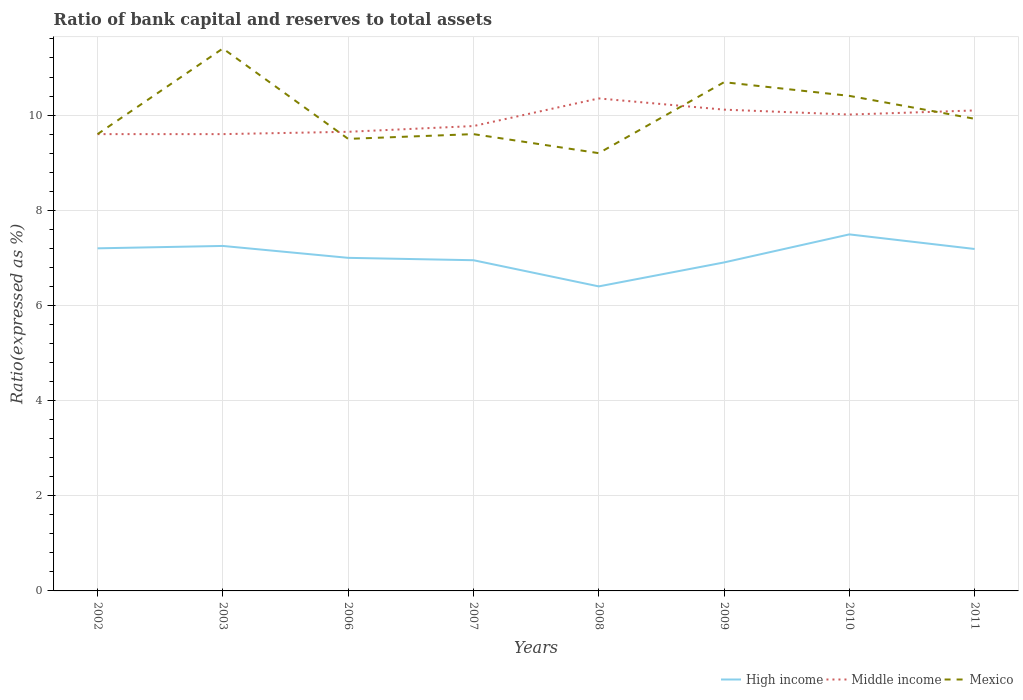Is the number of lines equal to the number of legend labels?
Make the answer very short. Yes. Across all years, what is the maximum ratio of bank capital and reserves to total assets in High income?
Your answer should be compact. 6.4. What is the total ratio of bank capital and reserves to total assets in High income in the graph?
Ensure brevity in your answer.  -0.59. What is the difference between the highest and the second highest ratio of bank capital and reserves to total assets in High income?
Offer a very short reply. 1.09. How many lines are there?
Keep it short and to the point. 3. Does the graph contain any zero values?
Offer a terse response. No. Does the graph contain grids?
Keep it short and to the point. Yes. How many legend labels are there?
Offer a terse response. 3. How are the legend labels stacked?
Ensure brevity in your answer.  Horizontal. What is the title of the graph?
Your answer should be very brief. Ratio of bank capital and reserves to total assets. What is the label or title of the Y-axis?
Keep it short and to the point. Ratio(expressed as %). What is the Ratio(expressed as %) of High income in 2002?
Make the answer very short. 7.2. What is the Ratio(expressed as %) in High income in 2003?
Make the answer very short. 7.25. What is the Ratio(expressed as %) of Middle income in 2003?
Your answer should be compact. 9.6. What is the Ratio(expressed as %) of Mexico in 2003?
Offer a terse response. 11.4. What is the Ratio(expressed as %) of High income in 2006?
Provide a succinct answer. 7. What is the Ratio(expressed as %) in Middle income in 2006?
Ensure brevity in your answer.  9.65. What is the Ratio(expressed as %) of Mexico in 2006?
Offer a terse response. 9.5. What is the Ratio(expressed as %) in High income in 2007?
Provide a succinct answer. 6.95. What is the Ratio(expressed as %) of Middle income in 2007?
Provide a short and direct response. 9.77. What is the Ratio(expressed as %) in Mexico in 2007?
Your response must be concise. 9.6. What is the Ratio(expressed as %) of High income in 2008?
Make the answer very short. 6.4. What is the Ratio(expressed as %) of Middle income in 2008?
Make the answer very short. 10.35. What is the Ratio(expressed as %) in High income in 2009?
Your answer should be very brief. 6.9. What is the Ratio(expressed as %) of Middle income in 2009?
Your response must be concise. 10.11. What is the Ratio(expressed as %) in Mexico in 2009?
Your answer should be very brief. 10.69. What is the Ratio(expressed as %) in High income in 2010?
Provide a short and direct response. 7.49. What is the Ratio(expressed as %) of Middle income in 2010?
Make the answer very short. 10.01. What is the Ratio(expressed as %) of Mexico in 2010?
Provide a succinct answer. 10.4. What is the Ratio(expressed as %) in High income in 2011?
Offer a very short reply. 7.19. What is the Ratio(expressed as %) of Middle income in 2011?
Make the answer very short. 10.1. What is the Ratio(expressed as %) in Mexico in 2011?
Give a very brief answer. 9.92. Across all years, what is the maximum Ratio(expressed as %) of High income?
Provide a succinct answer. 7.49. Across all years, what is the maximum Ratio(expressed as %) of Middle income?
Offer a very short reply. 10.35. Across all years, what is the maximum Ratio(expressed as %) in Mexico?
Give a very brief answer. 11.4. Across all years, what is the minimum Ratio(expressed as %) in High income?
Your response must be concise. 6.4. Across all years, what is the minimum Ratio(expressed as %) of Middle income?
Make the answer very short. 9.6. What is the total Ratio(expressed as %) in High income in the graph?
Give a very brief answer. 56.38. What is the total Ratio(expressed as %) in Middle income in the graph?
Your answer should be compact. 79.19. What is the total Ratio(expressed as %) of Mexico in the graph?
Your answer should be very brief. 80.32. What is the difference between the Ratio(expressed as %) of Mexico in 2002 and that in 2003?
Provide a short and direct response. -1.8. What is the difference between the Ratio(expressed as %) in Middle income in 2002 and that in 2006?
Your answer should be compact. -0.05. What is the difference between the Ratio(expressed as %) in Mexico in 2002 and that in 2006?
Your answer should be very brief. 0.1. What is the difference between the Ratio(expressed as %) of Middle income in 2002 and that in 2007?
Provide a short and direct response. -0.17. What is the difference between the Ratio(expressed as %) in Middle income in 2002 and that in 2008?
Give a very brief answer. -0.75. What is the difference between the Ratio(expressed as %) in High income in 2002 and that in 2009?
Provide a succinct answer. 0.3. What is the difference between the Ratio(expressed as %) of Middle income in 2002 and that in 2009?
Your response must be concise. -0.51. What is the difference between the Ratio(expressed as %) of Mexico in 2002 and that in 2009?
Offer a very short reply. -1.09. What is the difference between the Ratio(expressed as %) in High income in 2002 and that in 2010?
Offer a terse response. -0.29. What is the difference between the Ratio(expressed as %) of Middle income in 2002 and that in 2010?
Provide a succinct answer. -0.41. What is the difference between the Ratio(expressed as %) in Mexico in 2002 and that in 2010?
Your response must be concise. -0.8. What is the difference between the Ratio(expressed as %) in High income in 2002 and that in 2011?
Make the answer very short. 0.01. What is the difference between the Ratio(expressed as %) of Middle income in 2002 and that in 2011?
Your response must be concise. -0.5. What is the difference between the Ratio(expressed as %) of Mexico in 2002 and that in 2011?
Provide a succinct answer. -0.32. What is the difference between the Ratio(expressed as %) of High income in 2003 and that in 2006?
Offer a terse response. 0.25. What is the difference between the Ratio(expressed as %) in Middle income in 2003 and that in 2006?
Your answer should be compact. -0.05. What is the difference between the Ratio(expressed as %) of Middle income in 2003 and that in 2007?
Offer a very short reply. -0.17. What is the difference between the Ratio(expressed as %) of High income in 2003 and that in 2008?
Make the answer very short. 0.85. What is the difference between the Ratio(expressed as %) of Middle income in 2003 and that in 2008?
Provide a short and direct response. -0.75. What is the difference between the Ratio(expressed as %) in High income in 2003 and that in 2009?
Your answer should be compact. 0.35. What is the difference between the Ratio(expressed as %) of Middle income in 2003 and that in 2009?
Keep it short and to the point. -0.51. What is the difference between the Ratio(expressed as %) in Mexico in 2003 and that in 2009?
Your answer should be compact. 0.71. What is the difference between the Ratio(expressed as %) of High income in 2003 and that in 2010?
Ensure brevity in your answer.  -0.24. What is the difference between the Ratio(expressed as %) of Middle income in 2003 and that in 2010?
Provide a succinct answer. -0.41. What is the difference between the Ratio(expressed as %) of High income in 2003 and that in 2011?
Your answer should be very brief. 0.06. What is the difference between the Ratio(expressed as %) in Middle income in 2003 and that in 2011?
Your response must be concise. -0.5. What is the difference between the Ratio(expressed as %) in Mexico in 2003 and that in 2011?
Keep it short and to the point. 1.48. What is the difference between the Ratio(expressed as %) in High income in 2006 and that in 2007?
Provide a short and direct response. 0.05. What is the difference between the Ratio(expressed as %) in Middle income in 2006 and that in 2007?
Your response must be concise. -0.12. What is the difference between the Ratio(expressed as %) of High income in 2006 and that in 2008?
Provide a short and direct response. 0.6. What is the difference between the Ratio(expressed as %) of Middle income in 2006 and that in 2008?
Give a very brief answer. -0.7. What is the difference between the Ratio(expressed as %) in High income in 2006 and that in 2009?
Your answer should be compact. 0.1. What is the difference between the Ratio(expressed as %) of Middle income in 2006 and that in 2009?
Your response must be concise. -0.47. What is the difference between the Ratio(expressed as %) in Mexico in 2006 and that in 2009?
Provide a short and direct response. -1.19. What is the difference between the Ratio(expressed as %) of High income in 2006 and that in 2010?
Keep it short and to the point. -0.49. What is the difference between the Ratio(expressed as %) in Middle income in 2006 and that in 2010?
Keep it short and to the point. -0.36. What is the difference between the Ratio(expressed as %) of Mexico in 2006 and that in 2010?
Your response must be concise. -0.9. What is the difference between the Ratio(expressed as %) of High income in 2006 and that in 2011?
Give a very brief answer. -0.19. What is the difference between the Ratio(expressed as %) in Middle income in 2006 and that in 2011?
Make the answer very short. -0.45. What is the difference between the Ratio(expressed as %) in Mexico in 2006 and that in 2011?
Keep it short and to the point. -0.42. What is the difference between the Ratio(expressed as %) in High income in 2007 and that in 2008?
Your answer should be compact. 0.55. What is the difference between the Ratio(expressed as %) of Middle income in 2007 and that in 2008?
Offer a terse response. -0.58. What is the difference between the Ratio(expressed as %) of High income in 2007 and that in 2009?
Provide a short and direct response. 0.05. What is the difference between the Ratio(expressed as %) of Middle income in 2007 and that in 2009?
Your answer should be very brief. -0.34. What is the difference between the Ratio(expressed as %) of Mexico in 2007 and that in 2009?
Make the answer very short. -1.09. What is the difference between the Ratio(expressed as %) in High income in 2007 and that in 2010?
Keep it short and to the point. -0.54. What is the difference between the Ratio(expressed as %) in Middle income in 2007 and that in 2010?
Offer a very short reply. -0.24. What is the difference between the Ratio(expressed as %) in Mexico in 2007 and that in 2010?
Ensure brevity in your answer.  -0.8. What is the difference between the Ratio(expressed as %) in High income in 2007 and that in 2011?
Provide a short and direct response. -0.24. What is the difference between the Ratio(expressed as %) of Middle income in 2007 and that in 2011?
Ensure brevity in your answer.  -0.33. What is the difference between the Ratio(expressed as %) in Mexico in 2007 and that in 2011?
Your answer should be compact. -0.32. What is the difference between the Ratio(expressed as %) in High income in 2008 and that in 2009?
Give a very brief answer. -0.5. What is the difference between the Ratio(expressed as %) of Middle income in 2008 and that in 2009?
Keep it short and to the point. 0.24. What is the difference between the Ratio(expressed as %) of Mexico in 2008 and that in 2009?
Ensure brevity in your answer.  -1.49. What is the difference between the Ratio(expressed as %) of High income in 2008 and that in 2010?
Provide a short and direct response. -1.09. What is the difference between the Ratio(expressed as %) in Middle income in 2008 and that in 2010?
Your answer should be compact. 0.34. What is the difference between the Ratio(expressed as %) of Mexico in 2008 and that in 2010?
Offer a very short reply. -1.2. What is the difference between the Ratio(expressed as %) in High income in 2008 and that in 2011?
Your answer should be very brief. -0.79. What is the difference between the Ratio(expressed as %) of Middle income in 2008 and that in 2011?
Provide a short and direct response. 0.25. What is the difference between the Ratio(expressed as %) in Mexico in 2008 and that in 2011?
Make the answer very short. -0.72. What is the difference between the Ratio(expressed as %) of High income in 2009 and that in 2010?
Offer a very short reply. -0.59. What is the difference between the Ratio(expressed as %) of Middle income in 2009 and that in 2010?
Your answer should be very brief. 0.1. What is the difference between the Ratio(expressed as %) of Mexico in 2009 and that in 2010?
Your answer should be compact. 0.29. What is the difference between the Ratio(expressed as %) in High income in 2009 and that in 2011?
Give a very brief answer. -0.28. What is the difference between the Ratio(expressed as %) in Middle income in 2009 and that in 2011?
Your response must be concise. 0.02. What is the difference between the Ratio(expressed as %) of Mexico in 2009 and that in 2011?
Keep it short and to the point. 0.77. What is the difference between the Ratio(expressed as %) in High income in 2010 and that in 2011?
Offer a terse response. 0.31. What is the difference between the Ratio(expressed as %) in Middle income in 2010 and that in 2011?
Your response must be concise. -0.09. What is the difference between the Ratio(expressed as %) of Mexico in 2010 and that in 2011?
Provide a short and direct response. 0.48. What is the difference between the Ratio(expressed as %) of High income in 2002 and the Ratio(expressed as %) of Middle income in 2003?
Provide a succinct answer. -2.4. What is the difference between the Ratio(expressed as %) in High income in 2002 and the Ratio(expressed as %) in Mexico in 2003?
Provide a short and direct response. -4.2. What is the difference between the Ratio(expressed as %) of High income in 2002 and the Ratio(expressed as %) of Middle income in 2006?
Ensure brevity in your answer.  -2.45. What is the difference between the Ratio(expressed as %) in High income in 2002 and the Ratio(expressed as %) in Middle income in 2007?
Offer a terse response. -2.57. What is the difference between the Ratio(expressed as %) of High income in 2002 and the Ratio(expressed as %) of Middle income in 2008?
Give a very brief answer. -3.15. What is the difference between the Ratio(expressed as %) of High income in 2002 and the Ratio(expressed as %) of Mexico in 2008?
Provide a short and direct response. -2. What is the difference between the Ratio(expressed as %) in High income in 2002 and the Ratio(expressed as %) in Middle income in 2009?
Offer a terse response. -2.91. What is the difference between the Ratio(expressed as %) of High income in 2002 and the Ratio(expressed as %) of Mexico in 2009?
Offer a very short reply. -3.49. What is the difference between the Ratio(expressed as %) in Middle income in 2002 and the Ratio(expressed as %) in Mexico in 2009?
Offer a very short reply. -1.09. What is the difference between the Ratio(expressed as %) of High income in 2002 and the Ratio(expressed as %) of Middle income in 2010?
Offer a terse response. -2.81. What is the difference between the Ratio(expressed as %) in High income in 2002 and the Ratio(expressed as %) in Mexico in 2010?
Offer a very short reply. -3.2. What is the difference between the Ratio(expressed as %) of Middle income in 2002 and the Ratio(expressed as %) of Mexico in 2010?
Offer a very short reply. -0.8. What is the difference between the Ratio(expressed as %) in High income in 2002 and the Ratio(expressed as %) in Middle income in 2011?
Your answer should be very brief. -2.9. What is the difference between the Ratio(expressed as %) in High income in 2002 and the Ratio(expressed as %) in Mexico in 2011?
Ensure brevity in your answer.  -2.72. What is the difference between the Ratio(expressed as %) of Middle income in 2002 and the Ratio(expressed as %) of Mexico in 2011?
Your answer should be compact. -0.32. What is the difference between the Ratio(expressed as %) in High income in 2003 and the Ratio(expressed as %) in Middle income in 2006?
Offer a very short reply. -2.4. What is the difference between the Ratio(expressed as %) of High income in 2003 and the Ratio(expressed as %) of Mexico in 2006?
Provide a short and direct response. -2.25. What is the difference between the Ratio(expressed as %) of High income in 2003 and the Ratio(expressed as %) of Middle income in 2007?
Your response must be concise. -2.52. What is the difference between the Ratio(expressed as %) of High income in 2003 and the Ratio(expressed as %) of Mexico in 2007?
Your answer should be very brief. -2.35. What is the difference between the Ratio(expressed as %) of Middle income in 2003 and the Ratio(expressed as %) of Mexico in 2007?
Make the answer very short. 0. What is the difference between the Ratio(expressed as %) of High income in 2003 and the Ratio(expressed as %) of Middle income in 2008?
Offer a terse response. -3.1. What is the difference between the Ratio(expressed as %) of High income in 2003 and the Ratio(expressed as %) of Mexico in 2008?
Your response must be concise. -1.95. What is the difference between the Ratio(expressed as %) of Middle income in 2003 and the Ratio(expressed as %) of Mexico in 2008?
Provide a short and direct response. 0.4. What is the difference between the Ratio(expressed as %) of High income in 2003 and the Ratio(expressed as %) of Middle income in 2009?
Make the answer very short. -2.86. What is the difference between the Ratio(expressed as %) of High income in 2003 and the Ratio(expressed as %) of Mexico in 2009?
Your answer should be very brief. -3.44. What is the difference between the Ratio(expressed as %) in Middle income in 2003 and the Ratio(expressed as %) in Mexico in 2009?
Provide a succinct answer. -1.09. What is the difference between the Ratio(expressed as %) in High income in 2003 and the Ratio(expressed as %) in Middle income in 2010?
Offer a terse response. -2.76. What is the difference between the Ratio(expressed as %) in High income in 2003 and the Ratio(expressed as %) in Mexico in 2010?
Offer a terse response. -3.15. What is the difference between the Ratio(expressed as %) in Middle income in 2003 and the Ratio(expressed as %) in Mexico in 2010?
Your answer should be very brief. -0.8. What is the difference between the Ratio(expressed as %) in High income in 2003 and the Ratio(expressed as %) in Middle income in 2011?
Your answer should be compact. -2.85. What is the difference between the Ratio(expressed as %) of High income in 2003 and the Ratio(expressed as %) of Mexico in 2011?
Offer a very short reply. -2.67. What is the difference between the Ratio(expressed as %) of Middle income in 2003 and the Ratio(expressed as %) of Mexico in 2011?
Keep it short and to the point. -0.32. What is the difference between the Ratio(expressed as %) in High income in 2006 and the Ratio(expressed as %) in Middle income in 2007?
Ensure brevity in your answer.  -2.77. What is the difference between the Ratio(expressed as %) of Middle income in 2006 and the Ratio(expressed as %) of Mexico in 2007?
Give a very brief answer. 0.05. What is the difference between the Ratio(expressed as %) of High income in 2006 and the Ratio(expressed as %) of Middle income in 2008?
Provide a succinct answer. -3.35. What is the difference between the Ratio(expressed as %) of High income in 2006 and the Ratio(expressed as %) of Mexico in 2008?
Ensure brevity in your answer.  -2.2. What is the difference between the Ratio(expressed as %) of Middle income in 2006 and the Ratio(expressed as %) of Mexico in 2008?
Offer a very short reply. 0.45. What is the difference between the Ratio(expressed as %) of High income in 2006 and the Ratio(expressed as %) of Middle income in 2009?
Make the answer very short. -3.11. What is the difference between the Ratio(expressed as %) in High income in 2006 and the Ratio(expressed as %) in Mexico in 2009?
Provide a short and direct response. -3.69. What is the difference between the Ratio(expressed as %) in Middle income in 2006 and the Ratio(expressed as %) in Mexico in 2009?
Make the answer very short. -1.04. What is the difference between the Ratio(expressed as %) in High income in 2006 and the Ratio(expressed as %) in Middle income in 2010?
Your answer should be compact. -3.01. What is the difference between the Ratio(expressed as %) of High income in 2006 and the Ratio(expressed as %) of Mexico in 2010?
Provide a short and direct response. -3.4. What is the difference between the Ratio(expressed as %) of Middle income in 2006 and the Ratio(expressed as %) of Mexico in 2010?
Provide a succinct answer. -0.75. What is the difference between the Ratio(expressed as %) in High income in 2006 and the Ratio(expressed as %) in Middle income in 2011?
Provide a short and direct response. -3.1. What is the difference between the Ratio(expressed as %) in High income in 2006 and the Ratio(expressed as %) in Mexico in 2011?
Provide a short and direct response. -2.92. What is the difference between the Ratio(expressed as %) of Middle income in 2006 and the Ratio(expressed as %) of Mexico in 2011?
Your answer should be very brief. -0.27. What is the difference between the Ratio(expressed as %) of High income in 2007 and the Ratio(expressed as %) of Mexico in 2008?
Keep it short and to the point. -2.25. What is the difference between the Ratio(expressed as %) of Middle income in 2007 and the Ratio(expressed as %) of Mexico in 2008?
Offer a very short reply. 0.57. What is the difference between the Ratio(expressed as %) in High income in 2007 and the Ratio(expressed as %) in Middle income in 2009?
Keep it short and to the point. -3.16. What is the difference between the Ratio(expressed as %) of High income in 2007 and the Ratio(expressed as %) of Mexico in 2009?
Offer a terse response. -3.74. What is the difference between the Ratio(expressed as %) in Middle income in 2007 and the Ratio(expressed as %) in Mexico in 2009?
Provide a succinct answer. -0.92. What is the difference between the Ratio(expressed as %) of High income in 2007 and the Ratio(expressed as %) of Middle income in 2010?
Your response must be concise. -3.06. What is the difference between the Ratio(expressed as %) in High income in 2007 and the Ratio(expressed as %) in Mexico in 2010?
Your response must be concise. -3.45. What is the difference between the Ratio(expressed as %) in Middle income in 2007 and the Ratio(expressed as %) in Mexico in 2010?
Provide a short and direct response. -0.63. What is the difference between the Ratio(expressed as %) of High income in 2007 and the Ratio(expressed as %) of Middle income in 2011?
Provide a succinct answer. -3.15. What is the difference between the Ratio(expressed as %) in High income in 2007 and the Ratio(expressed as %) in Mexico in 2011?
Ensure brevity in your answer.  -2.97. What is the difference between the Ratio(expressed as %) in Middle income in 2007 and the Ratio(expressed as %) in Mexico in 2011?
Your answer should be compact. -0.15. What is the difference between the Ratio(expressed as %) of High income in 2008 and the Ratio(expressed as %) of Middle income in 2009?
Provide a succinct answer. -3.71. What is the difference between the Ratio(expressed as %) in High income in 2008 and the Ratio(expressed as %) in Mexico in 2009?
Give a very brief answer. -4.29. What is the difference between the Ratio(expressed as %) of Middle income in 2008 and the Ratio(expressed as %) of Mexico in 2009?
Ensure brevity in your answer.  -0.34. What is the difference between the Ratio(expressed as %) of High income in 2008 and the Ratio(expressed as %) of Middle income in 2010?
Make the answer very short. -3.61. What is the difference between the Ratio(expressed as %) of High income in 2008 and the Ratio(expressed as %) of Mexico in 2010?
Ensure brevity in your answer.  -4. What is the difference between the Ratio(expressed as %) of Middle income in 2008 and the Ratio(expressed as %) of Mexico in 2010?
Give a very brief answer. -0.05. What is the difference between the Ratio(expressed as %) of High income in 2008 and the Ratio(expressed as %) of Middle income in 2011?
Your response must be concise. -3.7. What is the difference between the Ratio(expressed as %) in High income in 2008 and the Ratio(expressed as %) in Mexico in 2011?
Your response must be concise. -3.52. What is the difference between the Ratio(expressed as %) in Middle income in 2008 and the Ratio(expressed as %) in Mexico in 2011?
Provide a short and direct response. 0.43. What is the difference between the Ratio(expressed as %) of High income in 2009 and the Ratio(expressed as %) of Middle income in 2010?
Ensure brevity in your answer.  -3.11. What is the difference between the Ratio(expressed as %) in High income in 2009 and the Ratio(expressed as %) in Mexico in 2010?
Provide a succinct answer. -3.5. What is the difference between the Ratio(expressed as %) in Middle income in 2009 and the Ratio(expressed as %) in Mexico in 2010?
Offer a terse response. -0.29. What is the difference between the Ratio(expressed as %) of High income in 2009 and the Ratio(expressed as %) of Middle income in 2011?
Offer a terse response. -3.19. What is the difference between the Ratio(expressed as %) of High income in 2009 and the Ratio(expressed as %) of Mexico in 2011?
Keep it short and to the point. -3.02. What is the difference between the Ratio(expressed as %) in Middle income in 2009 and the Ratio(expressed as %) in Mexico in 2011?
Keep it short and to the point. 0.19. What is the difference between the Ratio(expressed as %) of High income in 2010 and the Ratio(expressed as %) of Middle income in 2011?
Provide a succinct answer. -2.6. What is the difference between the Ratio(expressed as %) in High income in 2010 and the Ratio(expressed as %) in Mexico in 2011?
Offer a very short reply. -2.43. What is the difference between the Ratio(expressed as %) in Middle income in 2010 and the Ratio(expressed as %) in Mexico in 2011?
Keep it short and to the point. 0.09. What is the average Ratio(expressed as %) in High income per year?
Ensure brevity in your answer.  7.05. What is the average Ratio(expressed as %) of Middle income per year?
Make the answer very short. 9.9. What is the average Ratio(expressed as %) in Mexico per year?
Make the answer very short. 10.04. In the year 2003, what is the difference between the Ratio(expressed as %) of High income and Ratio(expressed as %) of Middle income?
Make the answer very short. -2.35. In the year 2003, what is the difference between the Ratio(expressed as %) of High income and Ratio(expressed as %) of Mexico?
Keep it short and to the point. -4.15. In the year 2006, what is the difference between the Ratio(expressed as %) of High income and Ratio(expressed as %) of Middle income?
Make the answer very short. -2.65. In the year 2006, what is the difference between the Ratio(expressed as %) in Middle income and Ratio(expressed as %) in Mexico?
Provide a succinct answer. 0.15. In the year 2007, what is the difference between the Ratio(expressed as %) in High income and Ratio(expressed as %) in Middle income?
Offer a terse response. -2.82. In the year 2007, what is the difference between the Ratio(expressed as %) of High income and Ratio(expressed as %) of Mexico?
Make the answer very short. -2.65. In the year 2007, what is the difference between the Ratio(expressed as %) of Middle income and Ratio(expressed as %) of Mexico?
Your answer should be very brief. 0.17. In the year 2008, what is the difference between the Ratio(expressed as %) of High income and Ratio(expressed as %) of Middle income?
Your answer should be very brief. -3.95. In the year 2008, what is the difference between the Ratio(expressed as %) in High income and Ratio(expressed as %) in Mexico?
Provide a succinct answer. -2.8. In the year 2008, what is the difference between the Ratio(expressed as %) in Middle income and Ratio(expressed as %) in Mexico?
Your answer should be compact. 1.15. In the year 2009, what is the difference between the Ratio(expressed as %) in High income and Ratio(expressed as %) in Middle income?
Make the answer very short. -3.21. In the year 2009, what is the difference between the Ratio(expressed as %) in High income and Ratio(expressed as %) in Mexico?
Provide a succinct answer. -3.79. In the year 2009, what is the difference between the Ratio(expressed as %) in Middle income and Ratio(expressed as %) in Mexico?
Your answer should be very brief. -0.58. In the year 2010, what is the difference between the Ratio(expressed as %) in High income and Ratio(expressed as %) in Middle income?
Offer a very short reply. -2.52. In the year 2010, what is the difference between the Ratio(expressed as %) in High income and Ratio(expressed as %) in Mexico?
Offer a very short reply. -2.91. In the year 2010, what is the difference between the Ratio(expressed as %) of Middle income and Ratio(expressed as %) of Mexico?
Give a very brief answer. -0.39. In the year 2011, what is the difference between the Ratio(expressed as %) in High income and Ratio(expressed as %) in Middle income?
Ensure brevity in your answer.  -2.91. In the year 2011, what is the difference between the Ratio(expressed as %) of High income and Ratio(expressed as %) of Mexico?
Your answer should be compact. -2.74. In the year 2011, what is the difference between the Ratio(expressed as %) in Middle income and Ratio(expressed as %) in Mexico?
Your answer should be compact. 0.18. What is the ratio of the Ratio(expressed as %) in Mexico in 2002 to that in 2003?
Your answer should be compact. 0.84. What is the ratio of the Ratio(expressed as %) of High income in 2002 to that in 2006?
Your answer should be compact. 1.03. What is the ratio of the Ratio(expressed as %) in Mexico in 2002 to that in 2006?
Your response must be concise. 1.01. What is the ratio of the Ratio(expressed as %) in High income in 2002 to that in 2007?
Offer a terse response. 1.04. What is the ratio of the Ratio(expressed as %) of Middle income in 2002 to that in 2007?
Keep it short and to the point. 0.98. What is the ratio of the Ratio(expressed as %) in Mexico in 2002 to that in 2007?
Provide a short and direct response. 1. What is the ratio of the Ratio(expressed as %) of Middle income in 2002 to that in 2008?
Offer a very short reply. 0.93. What is the ratio of the Ratio(expressed as %) of Mexico in 2002 to that in 2008?
Keep it short and to the point. 1.04. What is the ratio of the Ratio(expressed as %) of High income in 2002 to that in 2009?
Provide a succinct answer. 1.04. What is the ratio of the Ratio(expressed as %) of Middle income in 2002 to that in 2009?
Ensure brevity in your answer.  0.95. What is the ratio of the Ratio(expressed as %) of Mexico in 2002 to that in 2009?
Give a very brief answer. 0.9. What is the ratio of the Ratio(expressed as %) of High income in 2002 to that in 2010?
Keep it short and to the point. 0.96. What is the ratio of the Ratio(expressed as %) in Middle income in 2002 to that in 2010?
Make the answer very short. 0.96. What is the ratio of the Ratio(expressed as %) in Mexico in 2002 to that in 2010?
Your response must be concise. 0.92. What is the ratio of the Ratio(expressed as %) in Middle income in 2002 to that in 2011?
Provide a short and direct response. 0.95. What is the ratio of the Ratio(expressed as %) in Mexico in 2002 to that in 2011?
Offer a very short reply. 0.97. What is the ratio of the Ratio(expressed as %) of High income in 2003 to that in 2006?
Give a very brief answer. 1.04. What is the ratio of the Ratio(expressed as %) in Middle income in 2003 to that in 2006?
Make the answer very short. 0.99. What is the ratio of the Ratio(expressed as %) in High income in 2003 to that in 2007?
Provide a short and direct response. 1.04. What is the ratio of the Ratio(expressed as %) of Middle income in 2003 to that in 2007?
Your response must be concise. 0.98. What is the ratio of the Ratio(expressed as %) of Mexico in 2003 to that in 2007?
Keep it short and to the point. 1.19. What is the ratio of the Ratio(expressed as %) of High income in 2003 to that in 2008?
Your answer should be compact. 1.13. What is the ratio of the Ratio(expressed as %) of Middle income in 2003 to that in 2008?
Ensure brevity in your answer.  0.93. What is the ratio of the Ratio(expressed as %) of Mexico in 2003 to that in 2008?
Your answer should be compact. 1.24. What is the ratio of the Ratio(expressed as %) of High income in 2003 to that in 2009?
Give a very brief answer. 1.05. What is the ratio of the Ratio(expressed as %) of Middle income in 2003 to that in 2009?
Provide a succinct answer. 0.95. What is the ratio of the Ratio(expressed as %) of Mexico in 2003 to that in 2009?
Offer a very short reply. 1.07. What is the ratio of the Ratio(expressed as %) in High income in 2003 to that in 2010?
Provide a succinct answer. 0.97. What is the ratio of the Ratio(expressed as %) in Middle income in 2003 to that in 2010?
Offer a very short reply. 0.96. What is the ratio of the Ratio(expressed as %) of Mexico in 2003 to that in 2010?
Your response must be concise. 1.1. What is the ratio of the Ratio(expressed as %) of High income in 2003 to that in 2011?
Make the answer very short. 1.01. What is the ratio of the Ratio(expressed as %) of Middle income in 2003 to that in 2011?
Offer a very short reply. 0.95. What is the ratio of the Ratio(expressed as %) in Mexico in 2003 to that in 2011?
Provide a succinct answer. 1.15. What is the ratio of the Ratio(expressed as %) of High income in 2006 to that in 2007?
Ensure brevity in your answer.  1.01. What is the ratio of the Ratio(expressed as %) in Middle income in 2006 to that in 2007?
Your answer should be very brief. 0.99. What is the ratio of the Ratio(expressed as %) in Mexico in 2006 to that in 2007?
Give a very brief answer. 0.99. What is the ratio of the Ratio(expressed as %) in High income in 2006 to that in 2008?
Offer a terse response. 1.09. What is the ratio of the Ratio(expressed as %) in Middle income in 2006 to that in 2008?
Ensure brevity in your answer.  0.93. What is the ratio of the Ratio(expressed as %) in Mexico in 2006 to that in 2008?
Offer a terse response. 1.03. What is the ratio of the Ratio(expressed as %) of High income in 2006 to that in 2009?
Ensure brevity in your answer.  1.01. What is the ratio of the Ratio(expressed as %) of Middle income in 2006 to that in 2009?
Keep it short and to the point. 0.95. What is the ratio of the Ratio(expressed as %) of Mexico in 2006 to that in 2009?
Offer a very short reply. 0.89. What is the ratio of the Ratio(expressed as %) of High income in 2006 to that in 2010?
Give a very brief answer. 0.93. What is the ratio of the Ratio(expressed as %) of Middle income in 2006 to that in 2010?
Your answer should be compact. 0.96. What is the ratio of the Ratio(expressed as %) in Mexico in 2006 to that in 2010?
Keep it short and to the point. 0.91. What is the ratio of the Ratio(expressed as %) in High income in 2006 to that in 2011?
Your answer should be very brief. 0.97. What is the ratio of the Ratio(expressed as %) in Middle income in 2006 to that in 2011?
Offer a terse response. 0.96. What is the ratio of the Ratio(expressed as %) of Mexico in 2006 to that in 2011?
Keep it short and to the point. 0.96. What is the ratio of the Ratio(expressed as %) of High income in 2007 to that in 2008?
Your answer should be very brief. 1.09. What is the ratio of the Ratio(expressed as %) in Middle income in 2007 to that in 2008?
Provide a short and direct response. 0.94. What is the ratio of the Ratio(expressed as %) of Mexico in 2007 to that in 2008?
Make the answer very short. 1.04. What is the ratio of the Ratio(expressed as %) of High income in 2007 to that in 2009?
Make the answer very short. 1.01. What is the ratio of the Ratio(expressed as %) of Middle income in 2007 to that in 2009?
Offer a very short reply. 0.97. What is the ratio of the Ratio(expressed as %) of Mexico in 2007 to that in 2009?
Keep it short and to the point. 0.9. What is the ratio of the Ratio(expressed as %) of High income in 2007 to that in 2010?
Your response must be concise. 0.93. What is the ratio of the Ratio(expressed as %) of Middle income in 2007 to that in 2010?
Ensure brevity in your answer.  0.98. What is the ratio of the Ratio(expressed as %) in Mexico in 2007 to that in 2010?
Make the answer very short. 0.92. What is the ratio of the Ratio(expressed as %) in High income in 2007 to that in 2011?
Keep it short and to the point. 0.97. What is the ratio of the Ratio(expressed as %) of Middle income in 2007 to that in 2011?
Your answer should be very brief. 0.97. What is the ratio of the Ratio(expressed as %) of Mexico in 2007 to that in 2011?
Offer a very short reply. 0.97. What is the ratio of the Ratio(expressed as %) of High income in 2008 to that in 2009?
Offer a terse response. 0.93. What is the ratio of the Ratio(expressed as %) in Middle income in 2008 to that in 2009?
Provide a succinct answer. 1.02. What is the ratio of the Ratio(expressed as %) in Mexico in 2008 to that in 2009?
Your answer should be compact. 0.86. What is the ratio of the Ratio(expressed as %) in High income in 2008 to that in 2010?
Your answer should be very brief. 0.85. What is the ratio of the Ratio(expressed as %) of Middle income in 2008 to that in 2010?
Your response must be concise. 1.03. What is the ratio of the Ratio(expressed as %) in Mexico in 2008 to that in 2010?
Your response must be concise. 0.88. What is the ratio of the Ratio(expressed as %) of High income in 2008 to that in 2011?
Your response must be concise. 0.89. What is the ratio of the Ratio(expressed as %) in Middle income in 2008 to that in 2011?
Keep it short and to the point. 1.02. What is the ratio of the Ratio(expressed as %) of Mexico in 2008 to that in 2011?
Provide a short and direct response. 0.93. What is the ratio of the Ratio(expressed as %) of High income in 2009 to that in 2010?
Ensure brevity in your answer.  0.92. What is the ratio of the Ratio(expressed as %) in Middle income in 2009 to that in 2010?
Keep it short and to the point. 1.01. What is the ratio of the Ratio(expressed as %) of Mexico in 2009 to that in 2010?
Give a very brief answer. 1.03. What is the ratio of the Ratio(expressed as %) of High income in 2009 to that in 2011?
Your response must be concise. 0.96. What is the ratio of the Ratio(expressed as %) in Mexico in 2009 to that in 2011?
Make the answer very short. 1.08. What is the ratio of the Ratio(expressed as %) in High income in 2010 to that in 2011?
Offer a terse response. 1.04. What is the ratio of the Ratio(expressed as %) in Middle income in 2010 to that in 2011?
Give a very brief answer. 0.99. What is the ratio of the Ratio(expressed as %) of Mexico in 2010 to that in 2011?
Ensure brevity in your answer.  1.05. What is the difference between the highest and the second highest Ratio(expressed as %) in High income?
Make the answer very short. 0.24. What is the difference between the highest and the second highest Ratio(expressed as %) in Middle income?
Provide a succinct answer. 0.24. What is the difference between the highest and the second highest Ratio(expressed as %) in Mexico?
Provide a short and direct response. 0.71. What is the difference between the highest and the lowest Ratio(expressed as %) in High income?
Your response must be concise. 1.09. What is the difference between the highest and the lowest Ratio(expressed as %) in Mexico?
Your response must be concise. 2.2. 